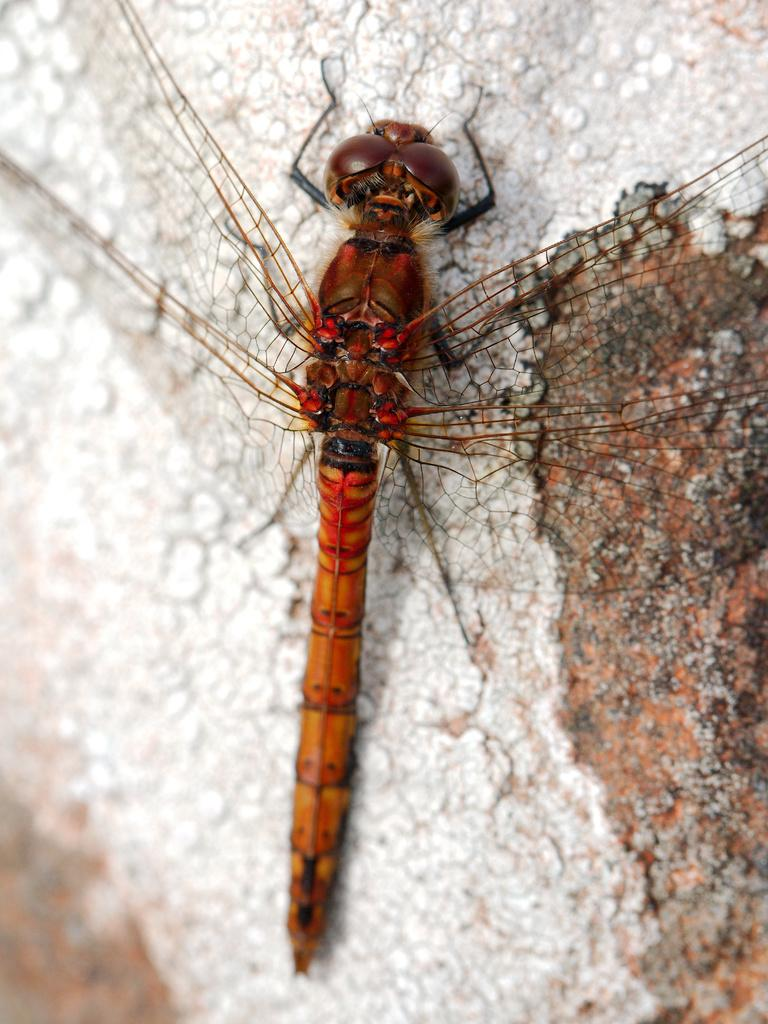What is the main subject of the image? There is a dragonfly in the image. Where is the dragonfly located in the image? The dragonfly is in the center of the image. What is the dragonfly resting on in the image? The dragonfly is on a surface in the image. How many sticks are being used by the dragonfly to stop in the image? There are no sticks present in the image, and the dragonfly is not using any to stop. Can you describe the kiss between the dragonfly and the surface in the image? There is no kiss between the dragonfly and the surface in the image; the dragonfly is simply resting on the surface. 